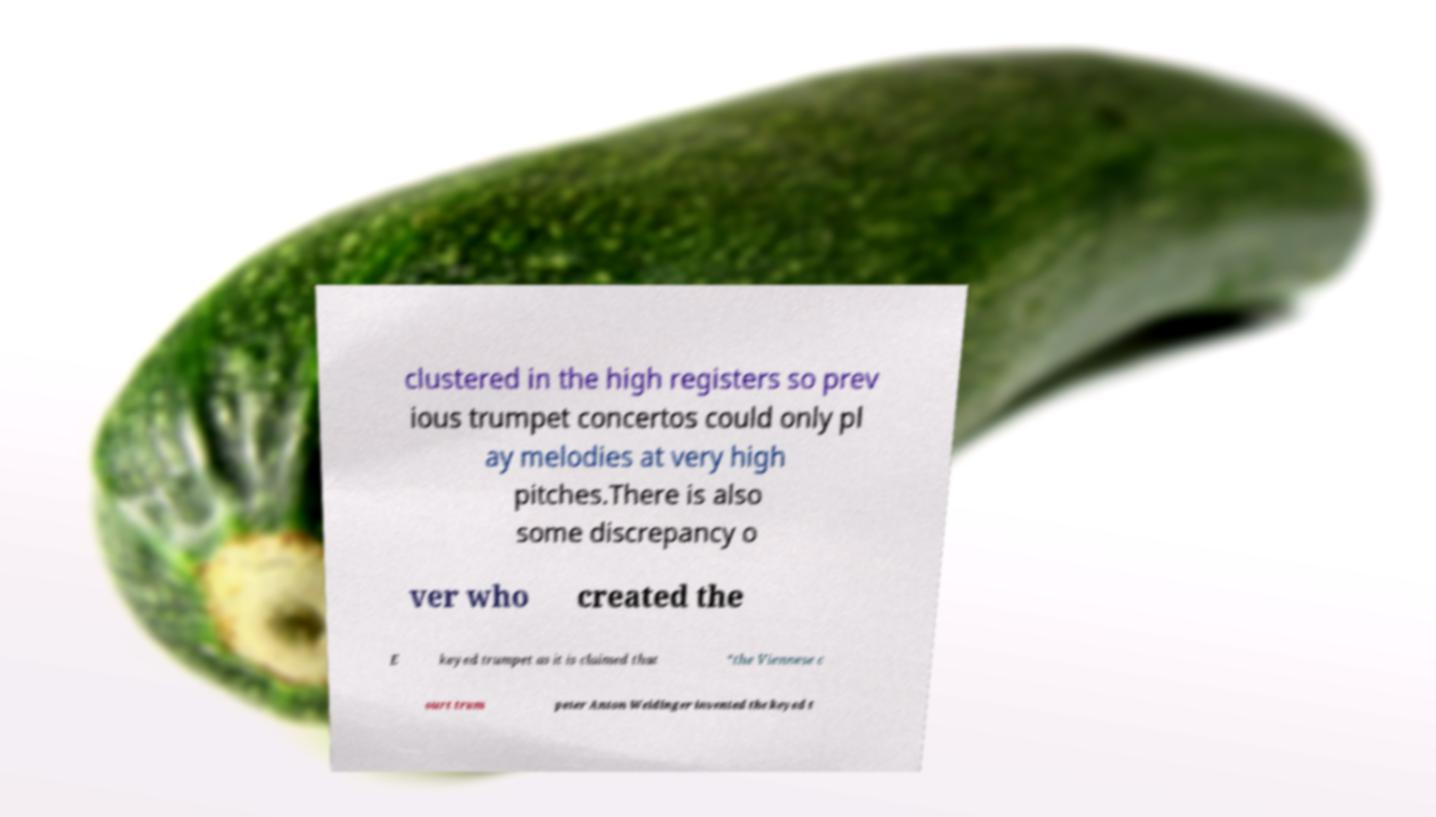What messages or text are displayed in this image? I need them in a readable, typed format. clustered in the high registers so prev ious trumpet concertos could only pl ay melodies at very high pitches.There is also some discrepancy o ver who created the E keyed trumpet as it is claimed that “the Viennese c ourt trum peter Anton Weidinger invented the keyed t 